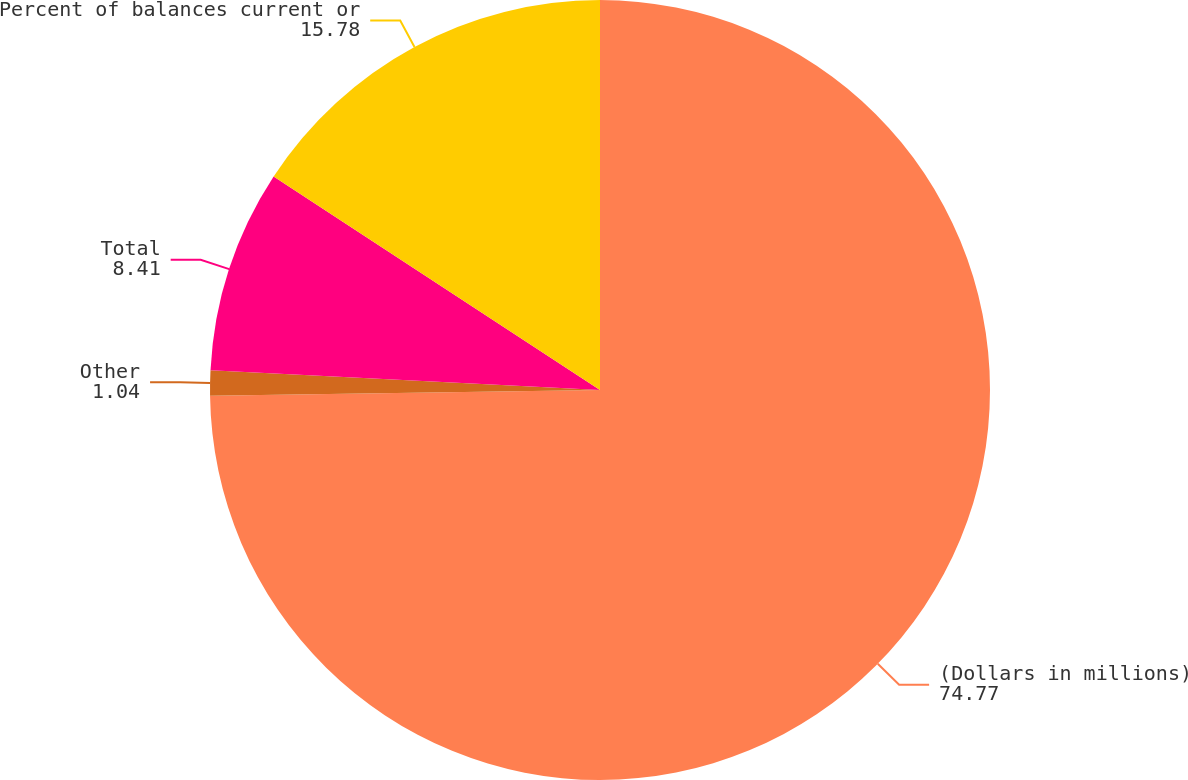<chart> <loc_0><loc_0><loc_500><loc_500><pie_chart><fcel>(Dollars in millions)<fcel>Other<fcel>Total<fcel>Percent of balances current or<nl><fcel>74.77%<fcel>1.04%<fcel>8.41%<fcel>15.78%<nl></chart> 